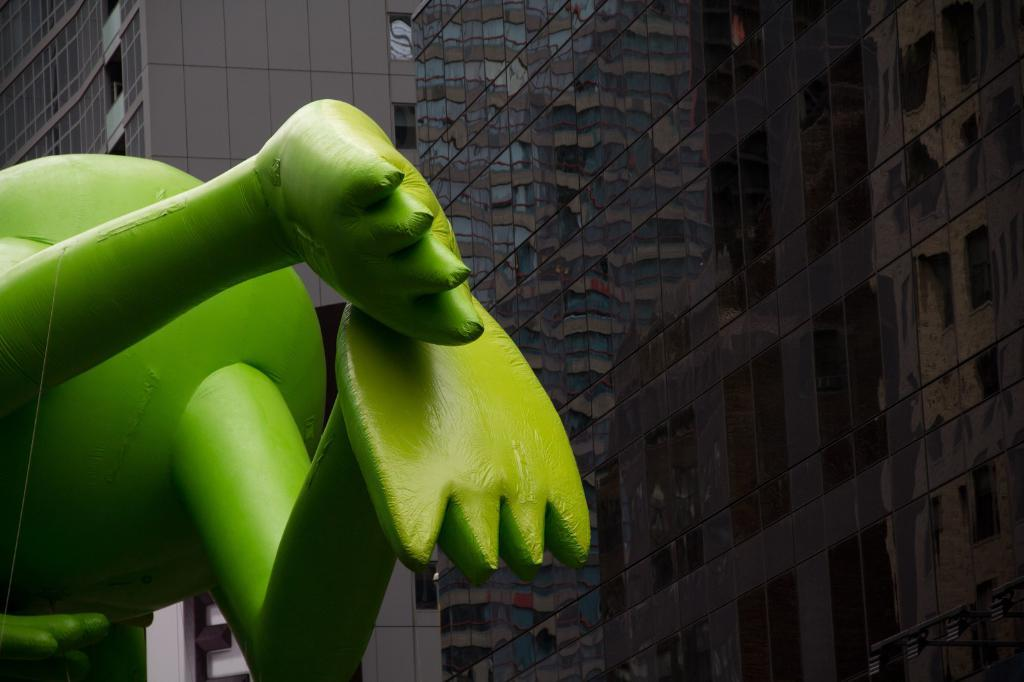What is located on the left side of the image? There is a statue on the left side of the image. What can be seen in the background of the image? There is a building in the background of the image. What feature of the building is visible in the image? The glasses (windows) of the building are visible in the image. What type of substance is being listed on the statue in the image? There is no substance or list present on the statue in the image. Is coal being used to power the building in the image? There is no information about the building's power source in the image, so it cannot be determined if coal is being used. 